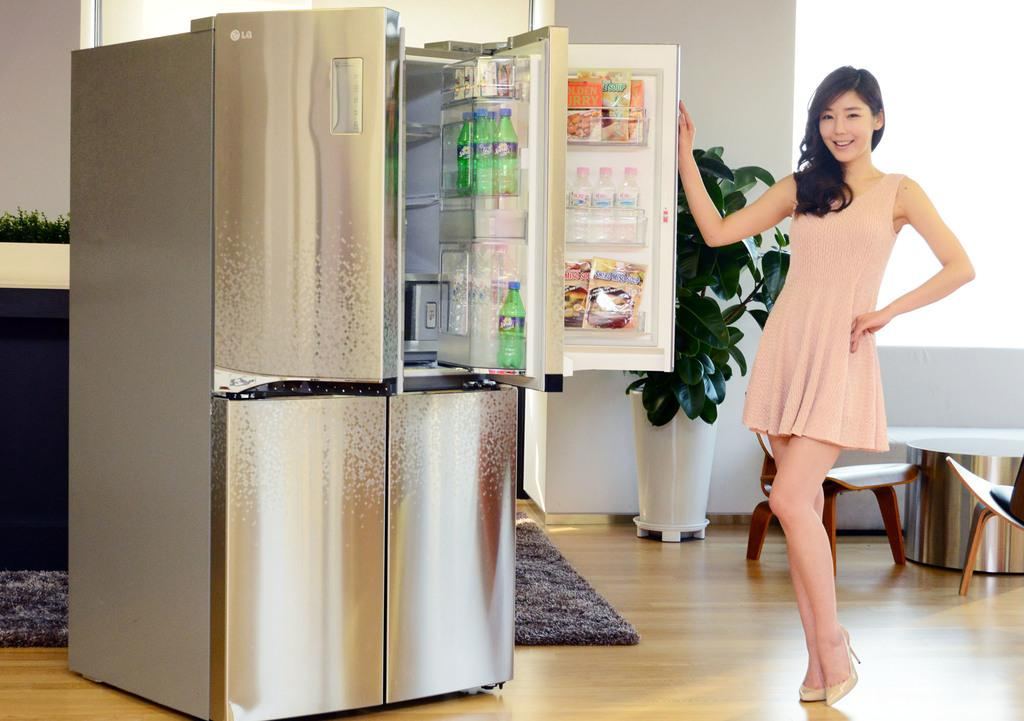<image>
Write a terse but informative summary of the picture. A girl opening a fridge showing products like Sprite 